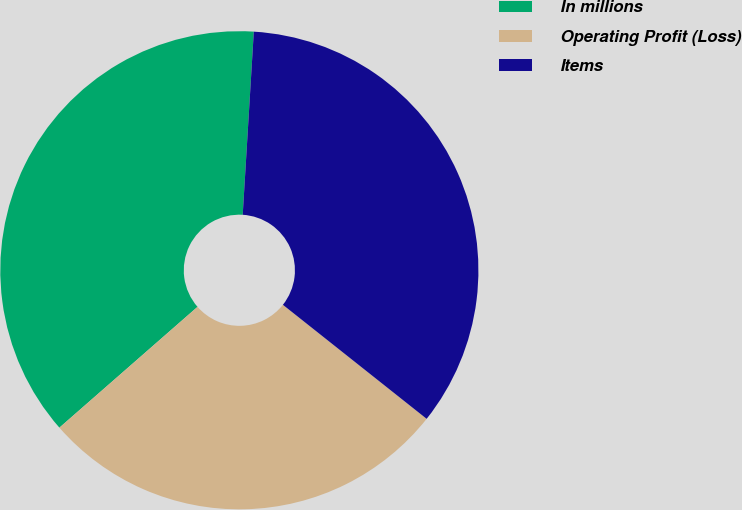Convert chart. <chart><loc_0><loc_0><loc_500><loc_500><pie_chart><fcel>In millions<fcel>Operating Profit (Loss)<fcel>Items<nl><fcel>37.4%<fcel>27.89%<fcel>34.71%<nl></chart> 